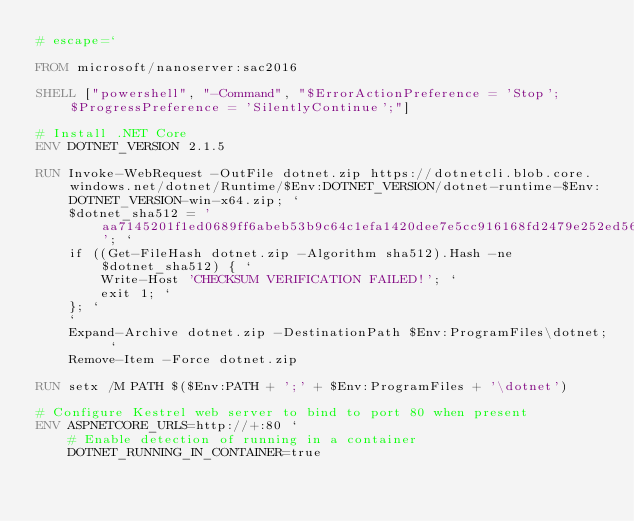<code> <loc_0><loc_0><loc_500><loc_500><_Dockerfile_># escape=`

FROM microsoft/nanoserver:sac2016

SHELL ["powershell", "-Command", "$ErrorActionPreference = 'Stop'; $ProgressPreference = 'SilentlyContinue';"]

# Install .NET Core
ENV DOTNET_VERSION 2.1.5

RUN Invoke-WebRequest -OutFile dotnet.zip https://dotnetcli.blob.core.windows.net/dotnet/Runtime/$Env:DOTNET_VERSION/dotnet-runtime-$Env:DOTNET_VERSION-win-x64.zip; `
    $dotnet_sha512 = 'aa7145201f1ed0689ff6abeb53b9c64c1efa1420dee7e5cc916168fd2479e252ed56b2492221f4038edbc73056accd9d4a46ec469155f2bdf0fc71bd909bd220'; `
    if ((Get-FileHash dotnet.zip -Algorithm sha512).Hash -ne $dotnet_sha512) { `
        Write-Host 'CHECKSUM VERIFICATION FAILED!'; `
        exit 1; `
    }; `
    `
    Expand-Archive dotnet.zip -DestinationPath $Env:ProgramFiles\dotnet; `
    Remove-Item -Force dotnet.zip

RUN setx /M PATH $($Env:PATH + ';' + $Env:ProgramFiles + '\dotnet')

# Configure Kestrel web server to bind to port 80 when present
ENV ASPNETCORE_URLS=http://+:80 `
    # Enable detection of running in a container
    DOTNET_RUNNING_IN_CONTAINER=true
</code> 